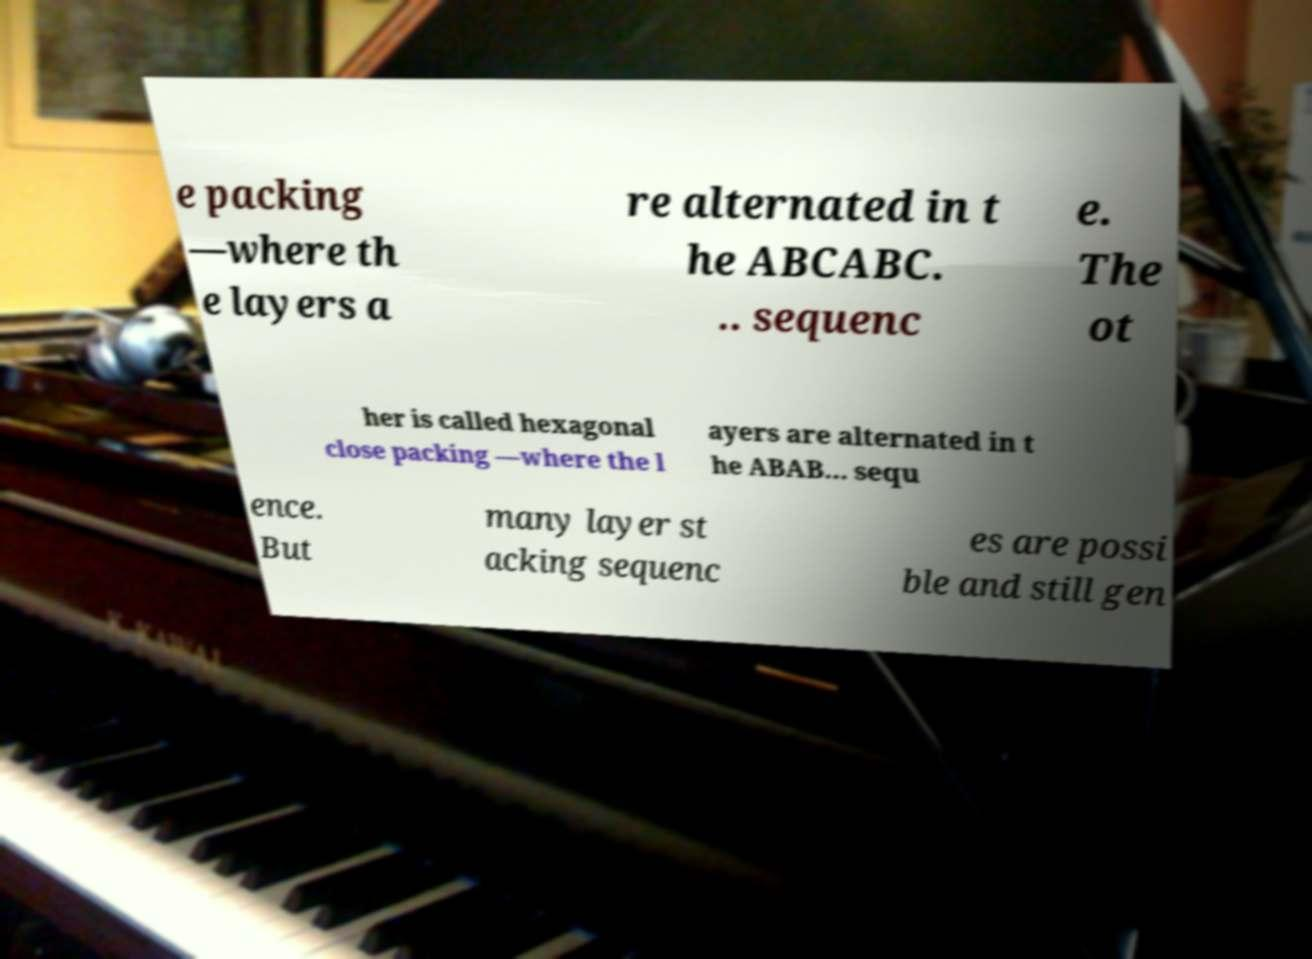There's text embedded in this image that I need extracted. Can you transcribe it verbatim? e packing —where th e layers a re alternated in t he ABCABC. .. sequenc e. The ot her is called hexagonal close packing —where the l ayers are alternated in t he ABAB... sequ ence. But many layer st acking sequenc es are possi ble and still gen 